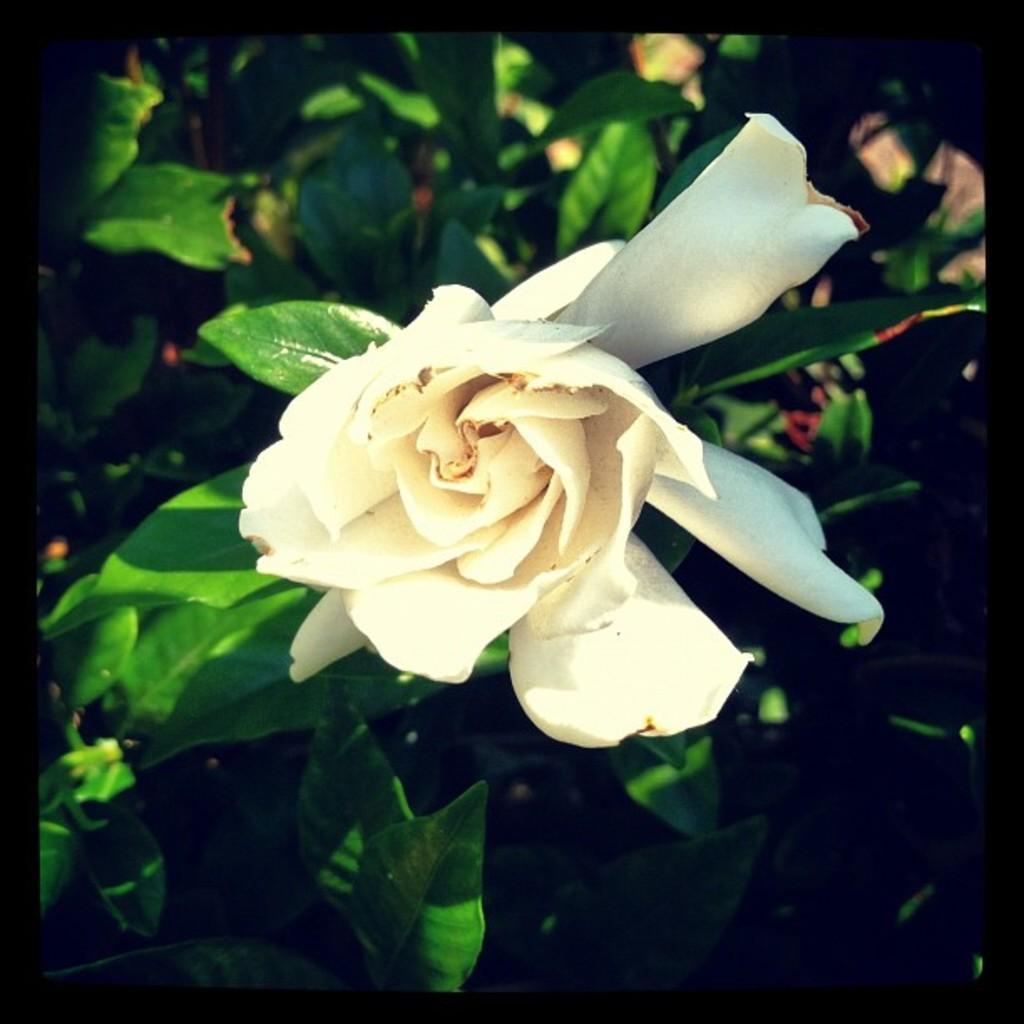Could you give a brief overview of what you see in this image? In this image I can see a white flower. In the background, I can see the leaves. 